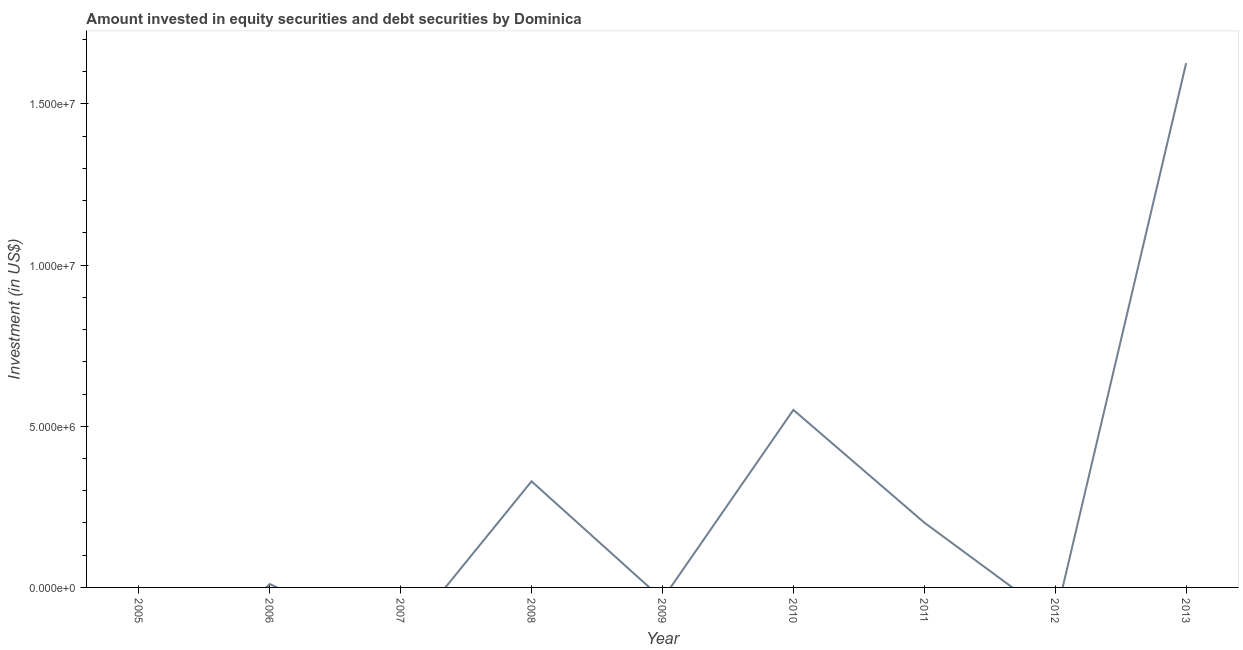What is the portfolio investment in 2011?
Provide a short and direct response. 2.01e+06. Across all years, what is the maximum portfolio investment?
Your answer should be very brief. 1.63e+07. In which year was the portfolio investment maximum?
Offer a very short reply. 2013. What is the sum of the portfolio investment?
Your answer should be compact. 2.72e+07. What is the difference between the portfolio investment in 2008 and 2013?
Provide a succinct answer. -1.30e+07. What is the average portfolio investment per year?
Your answer should be compact. 3.02e+06. What is the median portfolio investment?
Make the answer very short. 1.03e+05. What is the ratio of the portfolio investment in 2006 to that in 2013?
Ensure brevity in your answer.  0.01. Is the portfolio investment in 2006 less than that in 2010?
Your answer should be very brief. Yes. What is the difference between the highest and the second highest portfolio investment?
Make the answer very short. 1.08e+07. What is the difference between the highest and the lowest portfolio investment?
Keep it short and to the point. 1.63e+07. In how many years, is the portfolio investment greater than the average portfolio investment taken over all years?
Ensure brevity in your answer.  3. How many lines are there?
Your response must be concise. 1. What is the difference between two consecutive major ticks on the Y-axis?
Your answer should be very brief. 5.00e+06. Are the values on the major ticks of Y-axis written in scientific E-notation?
Ensure brevity in your answer.  Yes. Does the graph contain grids?
Give a very brief answer. No. What is the title of the graph?
Ensure brevity in your answer.  Amount invested in equity securities and debt securities by Dominica. What is the label or title of the Y-axis?
Offer a very short reply. Investment (in US$). What is the Investment (in US$) in 2006?
Ensure brevity in your answer.  1.03e+05. What is the Investment (in US$) of 2007?
Give a very brief answer. 0. What is the Investment (in US$) of 2008?
Provide a short and direct response. 3.29e+06. What is the Investment (in US$) in 2010?
Your answer should be very brief. 5.51e+06. What is the Investment (in US$) in 2011?
Your answer should be very brief. 2.01e+06. What is the Investment (in US$) of 2013?
Your answer should be compact. 1.63e+07. What is the difference between the Investment (in US$) in 2006 and 2008?
Your answer should be compact. -3.19e+06. What is the difference between the Investment (in US$) in 2006 and 2010?
Make the answer very short. -5.40e+06. What is the difference between the Investment (in US$) in 2006 and 2011?
Make the answer very short. -1.91e+06. What is the difference between the Investment (in US$) in 2006 and 2013?
Provide a succinct answer. -1.62e+07. What is the difference between the Investment (in US$) in 2008 and 2010?
Your answer should be very brief. -2.22e+06. What is the difference between the Investment (in US$) in 2008 and 2011?
Ensure brevity in your answer.  1.28e+06. What is the difference between the Investment (in US$) in 2008 and 2013?
Offer a terse response. -1.30e+07. What is the difference between the Investment (in US$) in 2010 and 2011?
Ensure brevity in your answer.  3.50e+06. What is the difference between the Investment (in US$) in 2010 and 2013?
Make the answer very short. -1.08e+07. What is the difference between the Investment (in US$) in 2011 and 2013?
Give a very brief answer. -1.43e+07. What is the ratio of the Investment (in US$) in 2006 to that in 2008?
Give a very brief answer. 0.03. What is the ratio of the Investment (in US$) in 2006 to that in 2010?
Provide a short and direct response. 0.02. What is the ratio of the Investment (in US$) in 2006 to that in 2011?
Keep it short and to the point. 0.05. What is the ratio of the Investment (in US$) in 2006 to that in 2013?
Your answer should be very brief. 0.01. What is the ratio of the Investment (in US$) in 2008 to that in 2010?
Give a very brief answer. 0.6. What is the ratio of the Investment (in US$) in 2008 to that in 2011?
Provide a succinct answer. 1.64. What is the ratio of the Investment (in US$) in 2008 to that in 2013?
Provide a succinct answer. 0.2. What is the ratio of the Investment (in US$) in 2010 to that in 2011?
Provide a succinct answer. 2.74. What is the ratio of the Investment (in US$) in 2010 to that in 2013?
Your answer should be very brief. 0.34. What is the ratio of the Investment (in US$) in 2011 to that in 2013?
Provide a short and direct response. 0.12. 